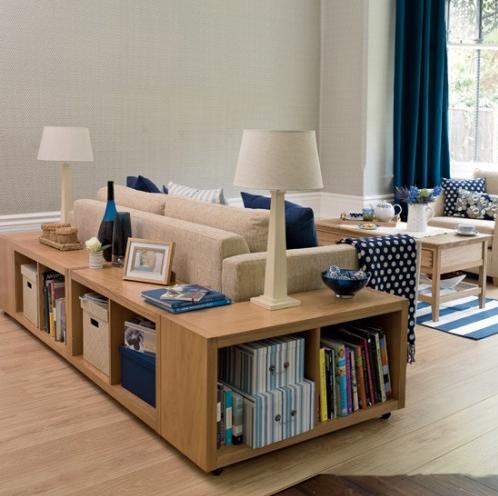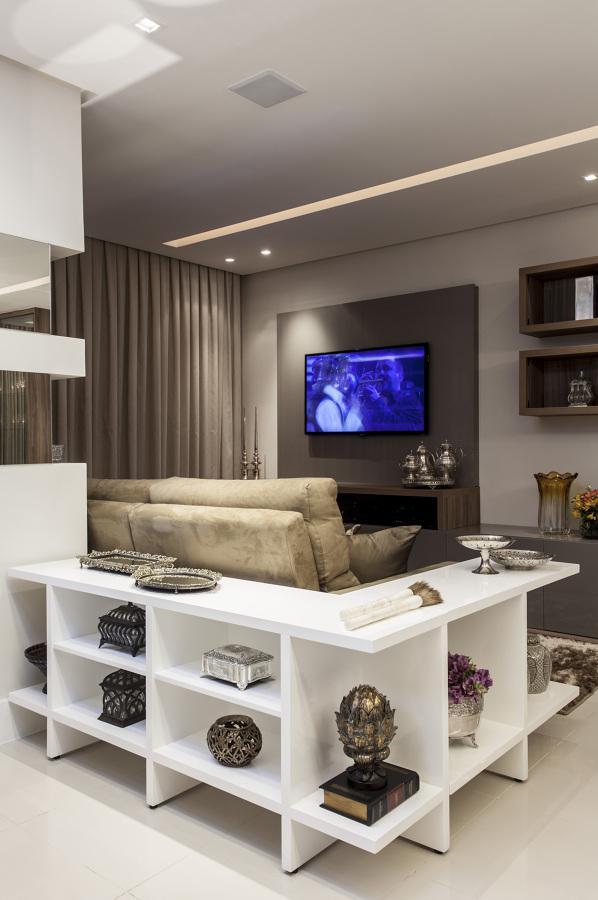The first image is the image on the left, the second image is the image on the right. Examine the images to the left and right. Is the description "The left image shows a woodgrain shelving unit that wraps around the back and side of a couch, with two lamps on its top." accurate? Answer yes or no. Yes. The first image is the image on the left, the second image is the image on the right. Examine the images to the left and right. Is the description "In at least one image there is a bookshelf couch with no more than three deep blue pillows." accurate? Answer yes or no. Yes. 